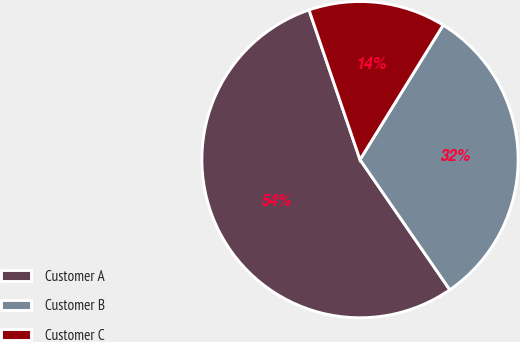Convert chart. <chart><loc_0><loc_0><loc_500><loc_500><pie_chart><fcel>Customer A<fcel>Customer B<fcel>Customer C<nl><fcel>54.39%<fcel>31.58%<fcel>14.04%<nl></chart> 